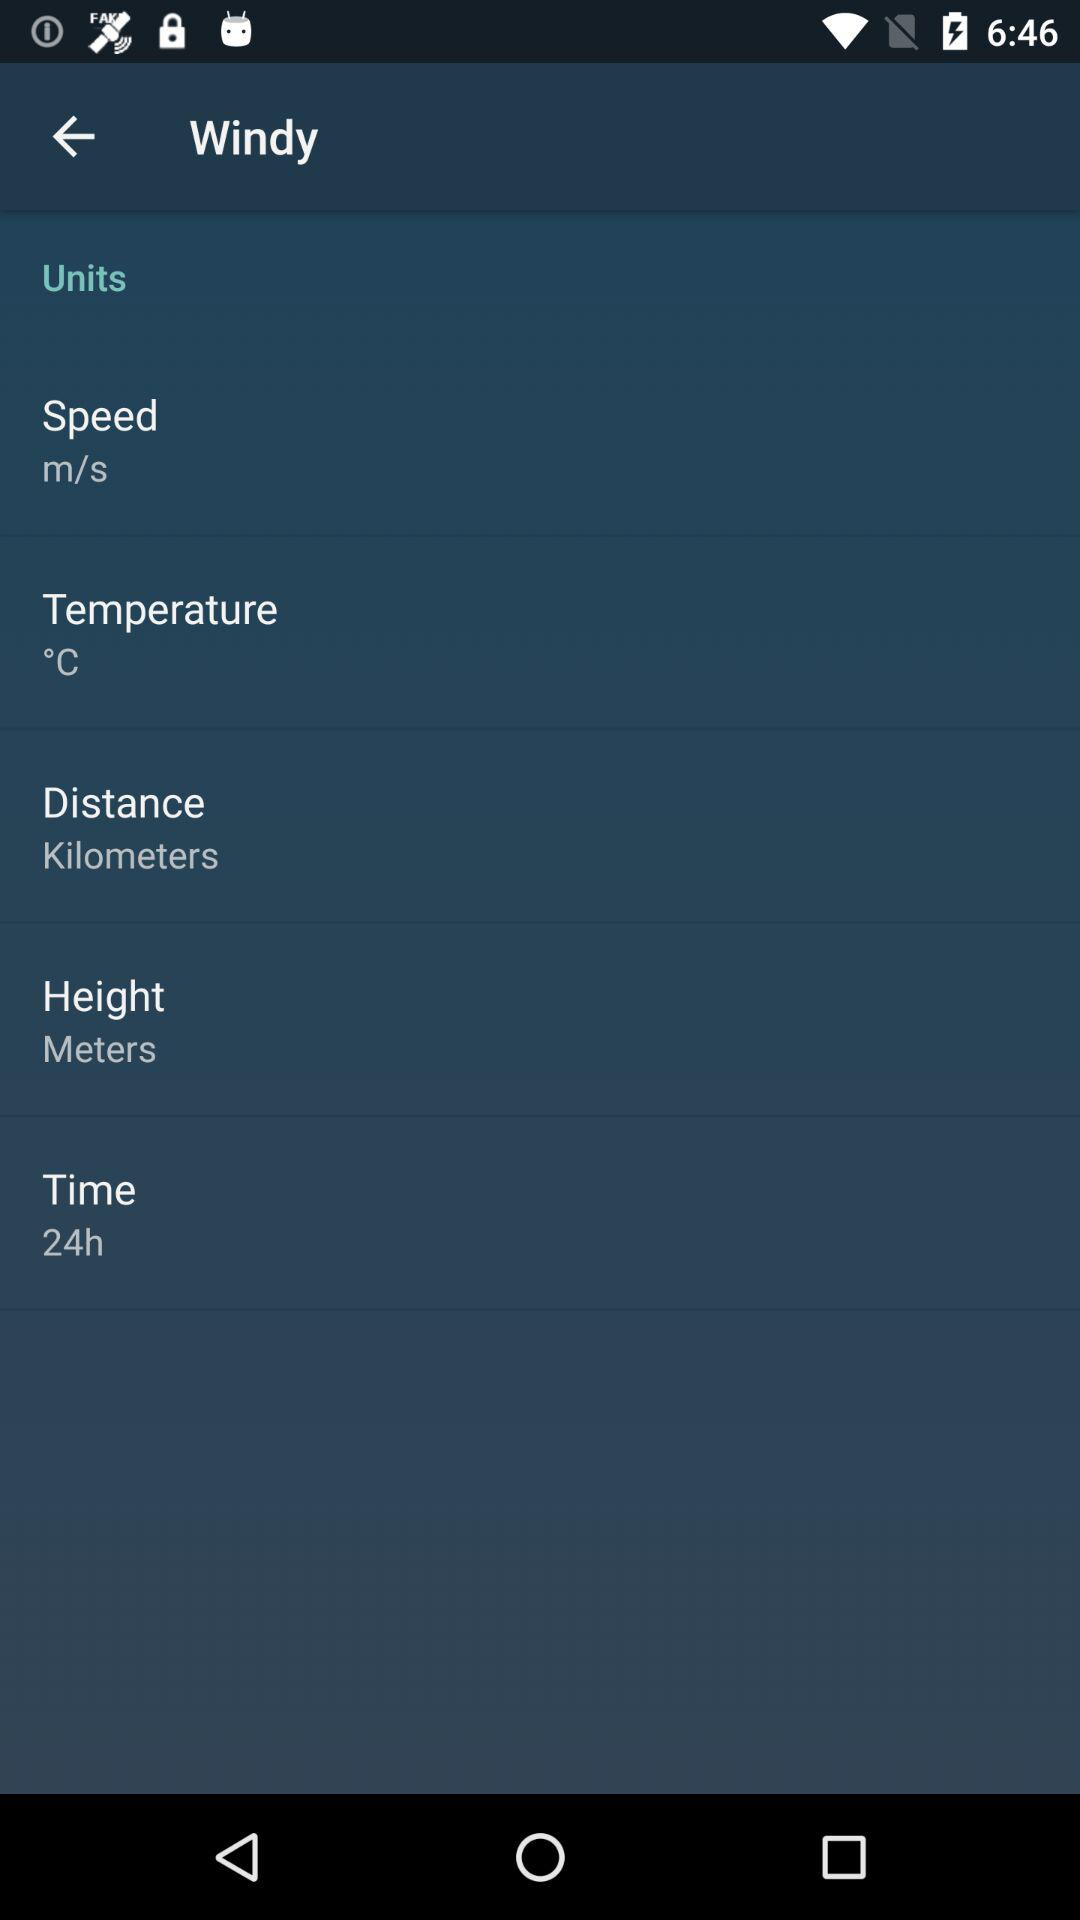What is the given unit of speed? The given unit is m/s. 